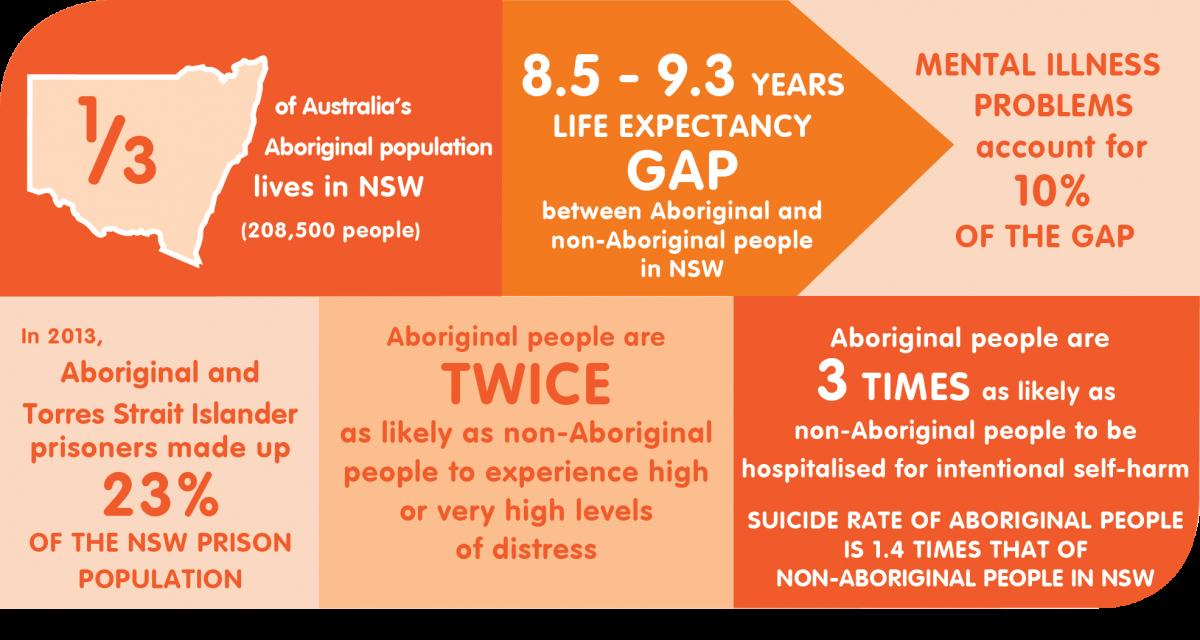Highlight a few significant elements in this photo. In 2013, 23% of the prison population in New South Wales (NSW) was made up of Aboriginal and Torres Strait Islander people. In the state of New South Wales, the population of Australia's Aboriginal people is approximately 208,500. The life expectancy gap between Aboriginal and non-Aboriginal people in NSW is 8.5 to 9.3 years, according to recent statistics. 